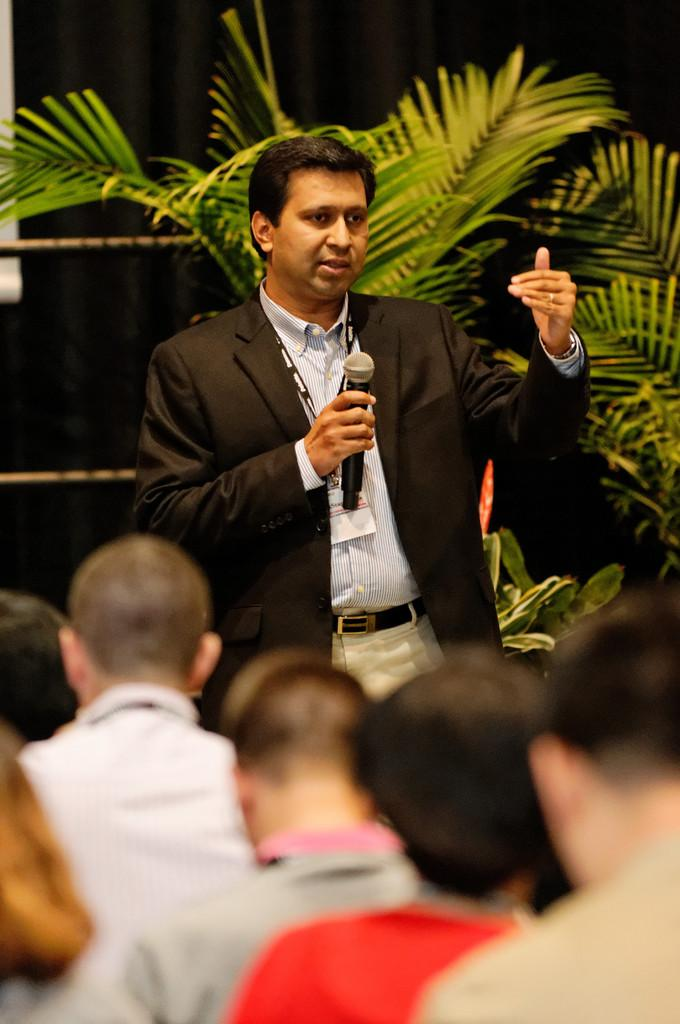How many people are in the image? There are people in the image, but the exact number is not specified. What is the man holding in the image? The man is holding a microphone in the image. What is the man doing with the microphone? The man is talking while holding the microphone. What can be seen in the background of the image? There are plants in the background of the image. How would you describe the lighting in the image? The background of the image is dark. How many eggs are visible in the image? There are no eggs present in the image. What type of son is playing the guitar in the image? There is no son or guitar present in the image. 